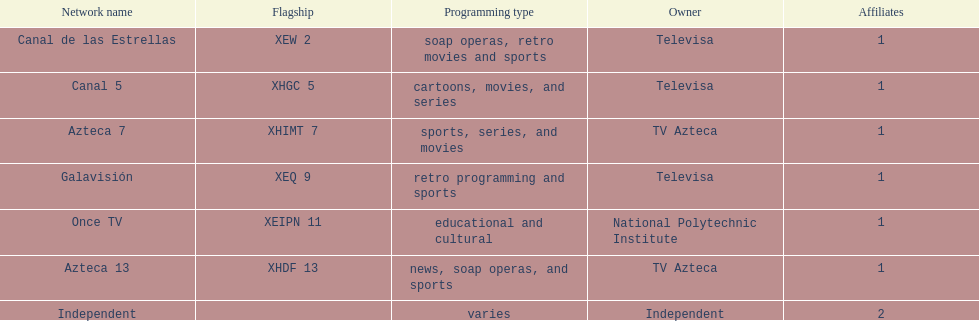How many networks does televisa own? 3. 